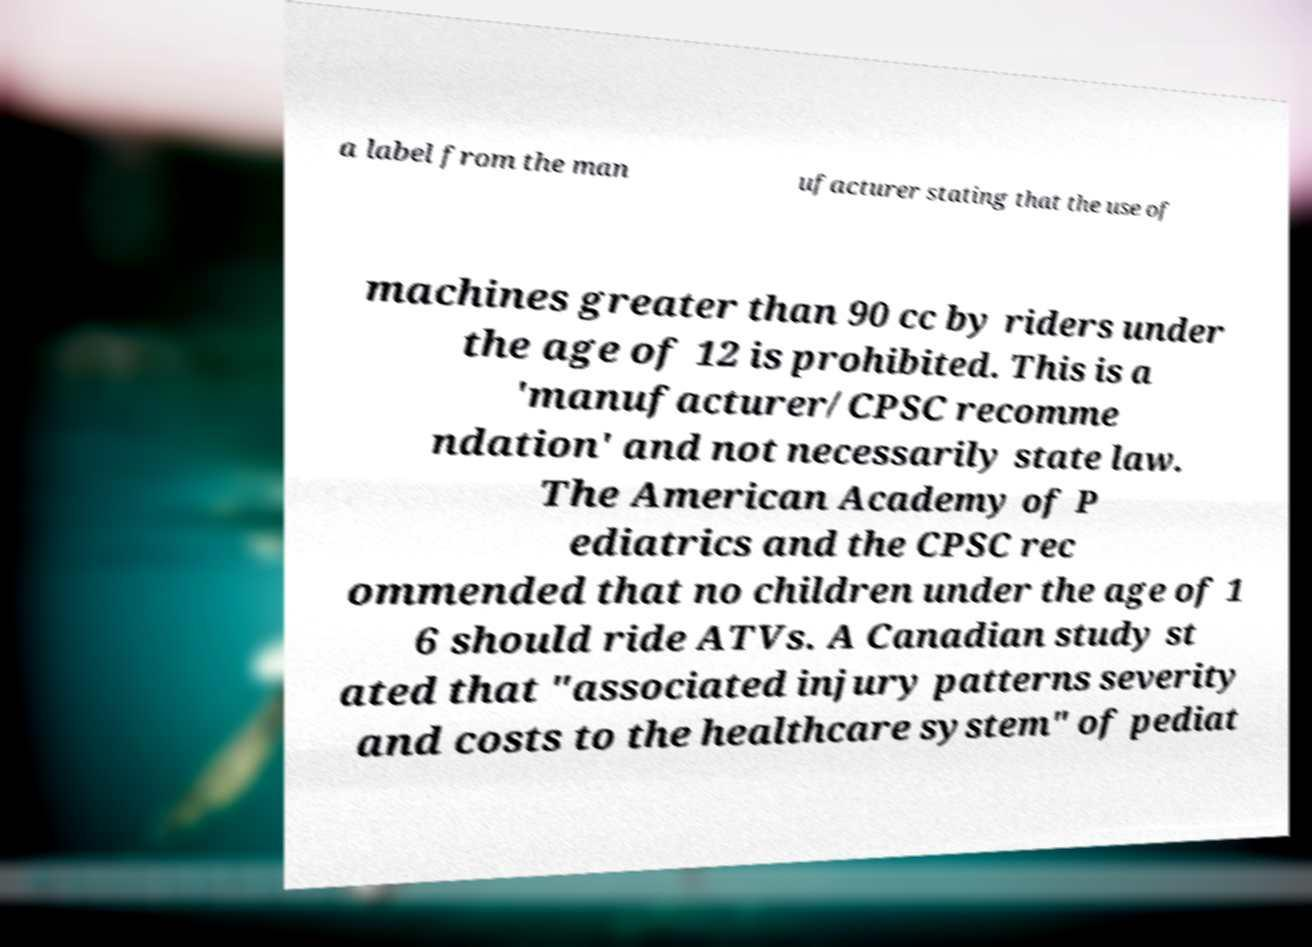Please read and relay the text visible in this image. What does it say? a label from the man ufacturer stating that the use of machines greater than 90 cc by riders under the age of 12 is prohibited. This is a 'manufacturer/CPSC recomme ndation' and not necessarily state law. The American Academy of P ediatrics and the CPSC rec ommended that no children under the age of 1 6 should ride ATVs. A Canadian study st ated that "associated injury patterns severity and costs to the healthcare system" of pediat 